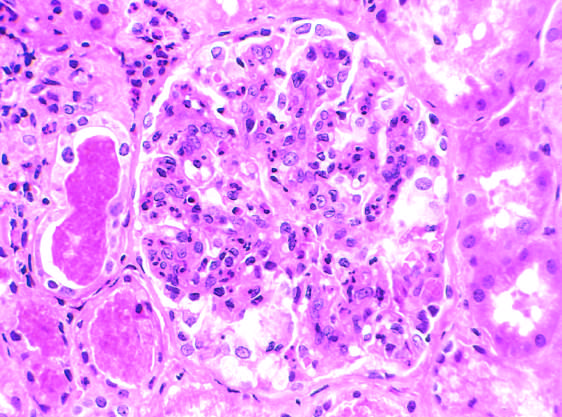what are in the tubules?
Answer the question using a single word or phrase. The red blood cell casts 